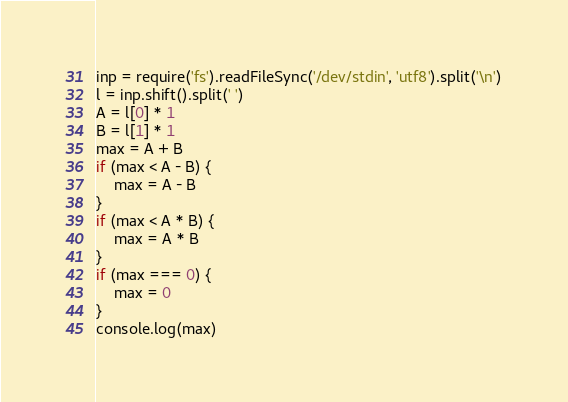<code> <loc_0><loc_0><loc_500><loc_500><_JavaScript_>inp = require('fs').readFileSync('/dev/stdin', 'utf8').split('\n')
l = inp.shift().split(' ')
A = l[0] * 1
B = l[1] * 1
max = A + B
if (max < A - B) {
    max = A - B
}
if (max < A * B) {
    max = A * B
}
if (max === 0) {
    max = 0
}
console.log(max)</code> 